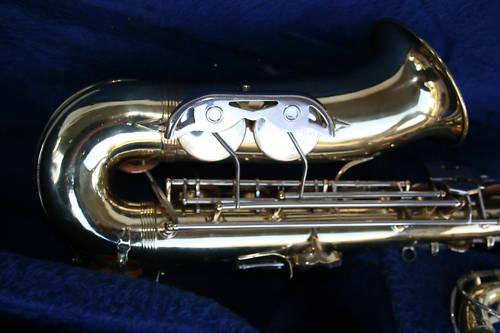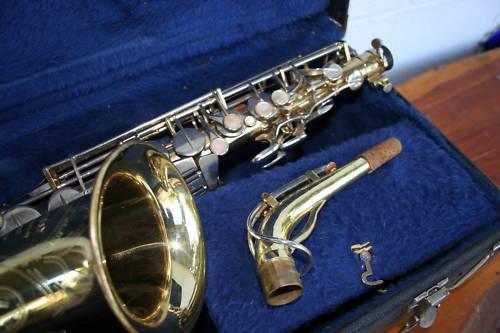The first image is the image on the left, the second image is the image on the right. Considering the images on both sides, is "The left image shows a saxophone displayed in front of an open black case, and the right image features a saxophone displayed without a case." valid? Answer yes or no. No. 